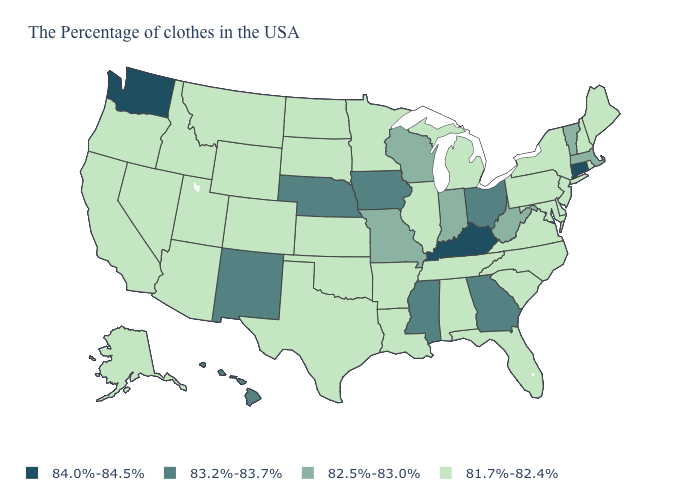Which states have the lowest value in the MidWest?
Be succinct. Michigan, Illinois, Minnesota, Kansas, South Dakota, North Dakota. Which states have the lowest value in the South?
Give a very brief answer. Delaware, Maryland, Virginia, North Carolina, South Carolina, Florida, Alabama, Tennessee, Louisiana, Arkansas, Oklahoma, Texas. What is the value of Florida?
Give a very brief answer. 81.7%-82.4%. What is the value of Wyoming?
Answer briefly. 81.7%-82.4%. Name the states that have a value in the range 84.0%-84.5%?
Write a very short answer. Connecticut, Kentucky, Washington. Name the states that have a value in the range 84.0%-84.5%?
Write a very short answer. Connecticut, Kentucky, Washington. Is the legend a continuous bar?
Concise answer only. No. Does New York have a lower value than Louisiana?
Short answer required. No. Name the states that have a value in the range 84.0%-84.5%?
Be succinct. Connecticut, Kentucky, Washington. Does Kentucky have the highest value in the USA?
Answer briefly. Yes. What is the lowest value in the MidWest?
Concise answer only. 81.7%-82.4%. How many symbols are there in the legend?
Be succinct. 4. Name the states that have a value in the range 82.5%-83.0%?
Write a very short answer. Massachusetts, Vermont, West Virginia, Indiana, Wisconsin, Missouri. Among the states that border Oregon , does Washington have the lowest value?
Short answer required. No. Name the states that have a value in the range 84.0%-84.5%?
Write a very short answer. Connecticut, Kentucky, Washington. 